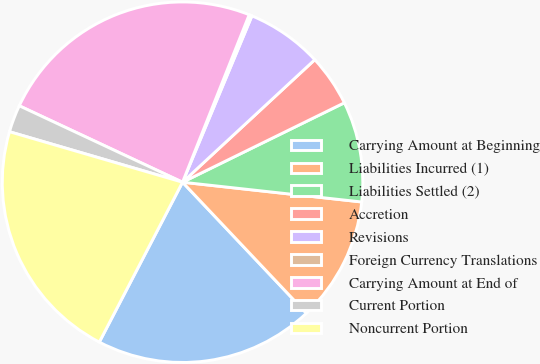Convert chart. <chart><loc_0><loc_0><loc_500><loc_500><pie_chart><fcel>Carrying Amount at Beginning<fcel>Liabilities Incurred (1)<fcel>Liabilities Settled (2)<fcel>Accretion<fcel>Revisions<fcel>Foreign Currency Translations<fcel>Carrying Amount at End of<fcel>Current Portion<fcel>Noncurrent Portion<nl><fcel>19.69%<fcel>11.2%<fcel>9.01%<fcel>4.63%<fcel>6.82%<fcel>0.26%<fcel>24.06%<fcel>2.45%<fcel>21.88%<nl></chart> 